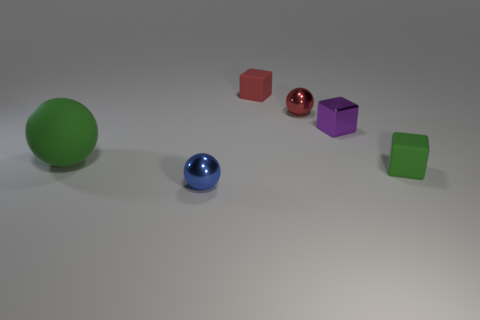Subtract all matte cubes. How many cubes are left? 1 Add 2 cyan spheres. How many objects exist? 8 Add 1 purple metal cubes. How many purple metal cubes are left? 2 Add 5 small purple metal blocks. How many small purple metal blocks exist? 6 Subtract 1 red balls. How many objects are left? 5 Subtract all cyan balls. Subtract all metallic blocks. How many objects are left? 5 